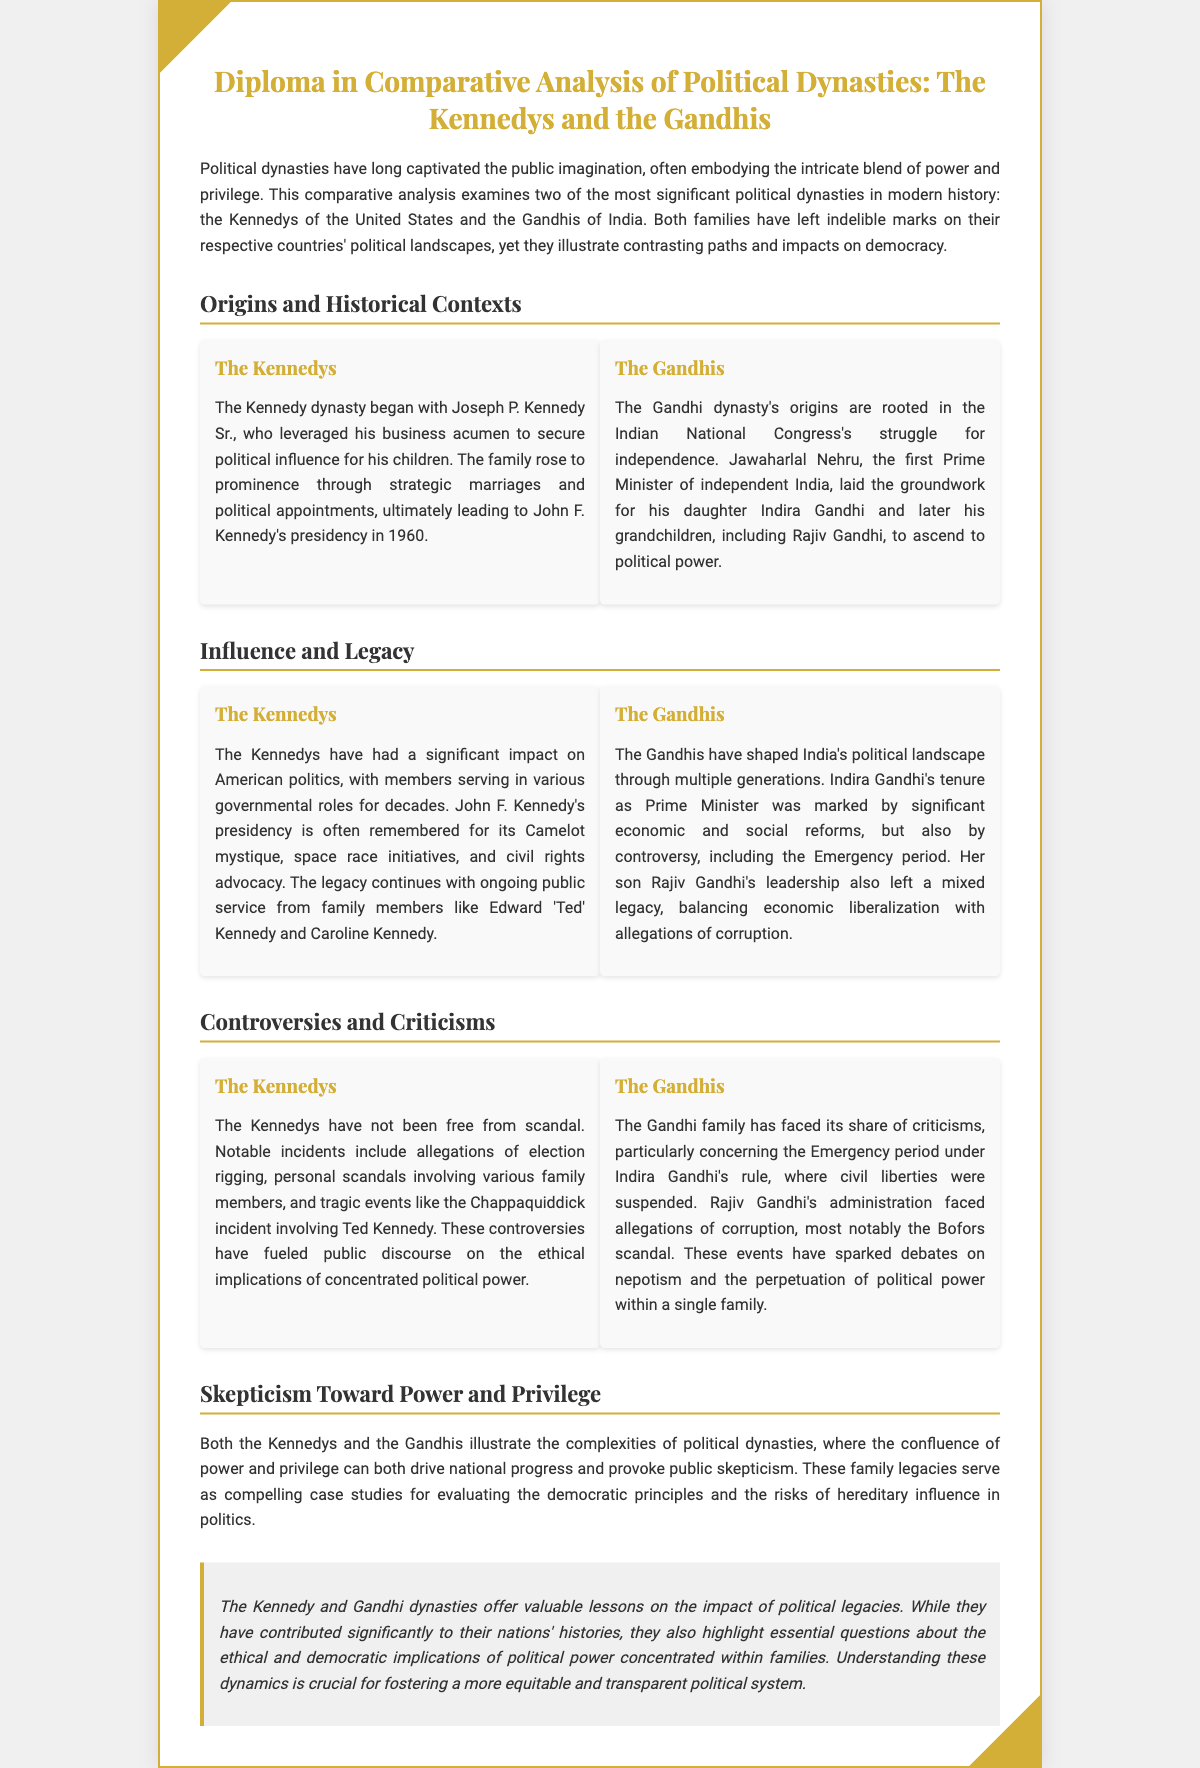What is the primary focus of the diploma? The diploma examines the comparative analysis of two significant political dynasties: the Kennedys of the United States and the Gandhis of India.
Answer: Comparative analysis of political dynasties Who was the first Prime Minister of independent India? The document states that Jawaharlal Nehru was the first Prime Minister of independent India, which is a key historical fact referenced in the section on origins.
Answer: Jawaharlal Nehru What significant scandal is mentioned involving Ted Kennedy? The document references the Chappaquiddick incident as a notable scandal involving Ted Kennedy, illustrating controversies faced by the Kennedy family.
Answer: Chappaquiddick Which family is associated with the term "Camelot"? The term "Camelot" is associated with John F. Kennedy's presidency, reflecting the mystique and legacy of the Kennedy family.
Answer: The Kennedys What political period under Indira Gandhi is described as controversial? The Emergency period under Indira Gandhi's rule is described as a controversial time, highlighting criticisms against the Gandhi family.
Answer: Emergency period What is highlighted as a key lesson from both dynasties? The document discusses the ethical and democratic implications of concentrated political power within families as a key lesson from the Kennedy and Gandhi dynasties.
Answer: Ethical and democratic implications What role did strategic marriages play in the Kennedy dynasty? The document explains that strategic marriages helped the Kennedy family secure political influence and rise to prominence.
Answer: Political influence How does the document characterize the legacy of Rajiv Gandhi? The document states that Rajiv Gandhi's leadership left a mixed legacy, balancing economic liberalization with allegations of corruption.
Answer: Mixed legacy 